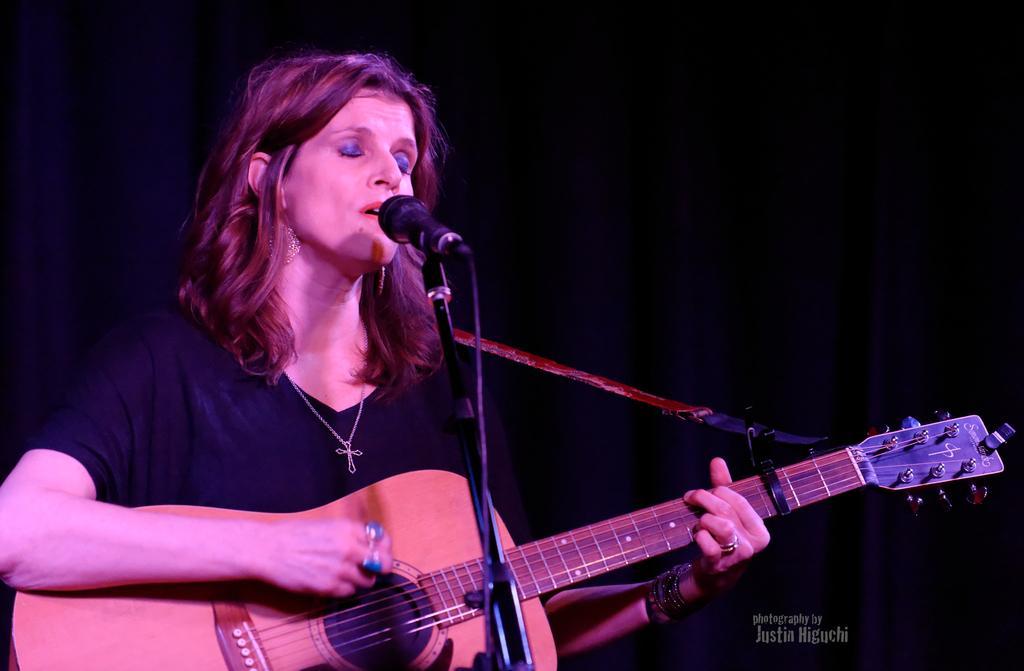Please provide a concise description of this image. In the image we can see there is a woman who is holding guitar in her hand. 